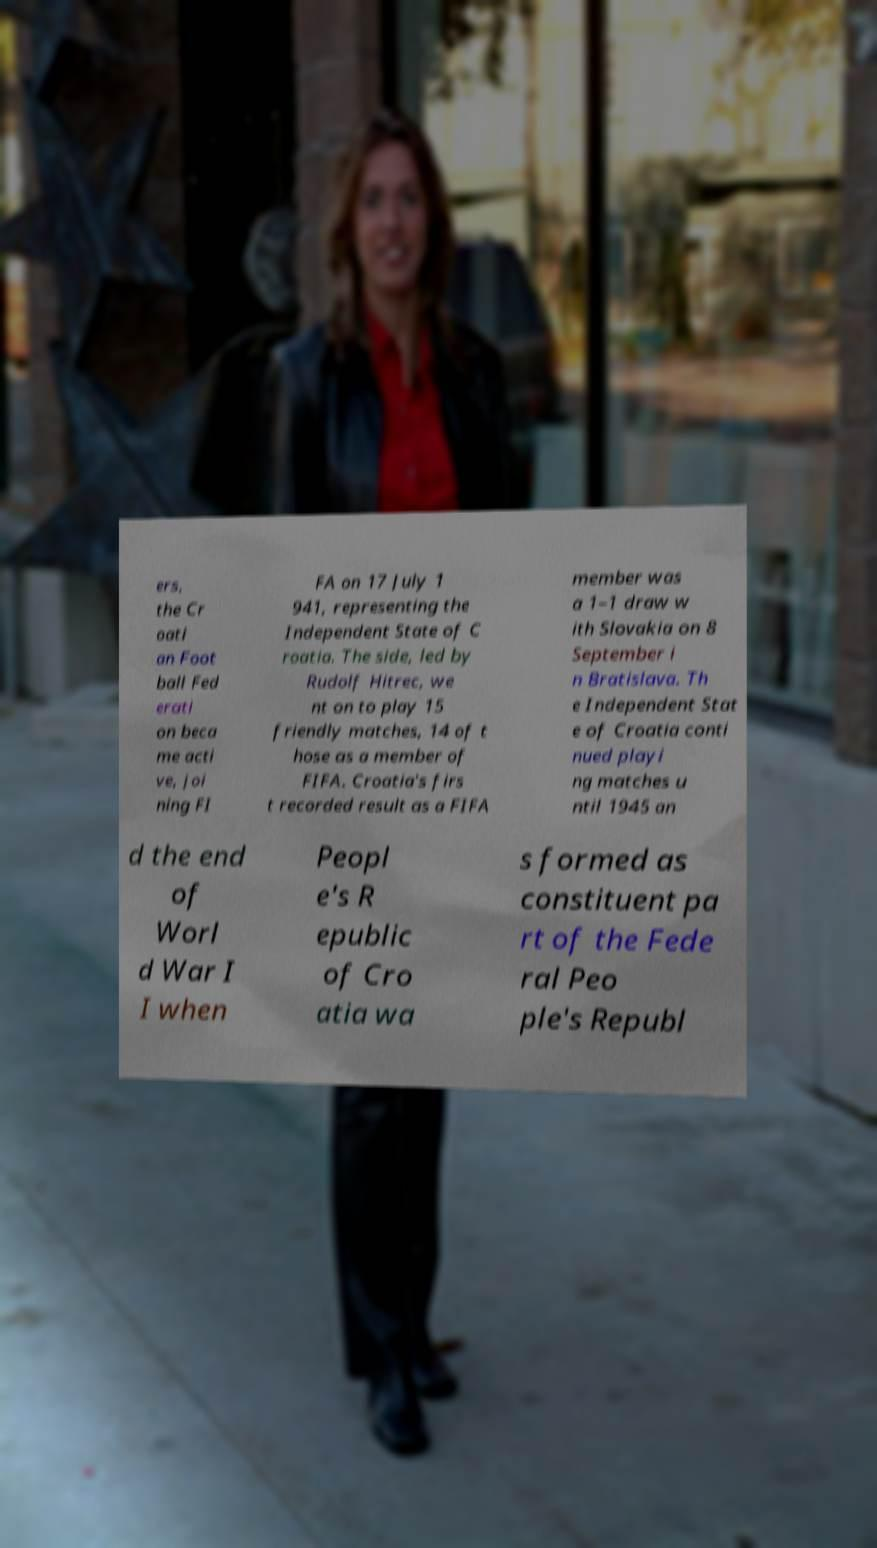For documentation purposes, I need the text within this image transcribed. Could you provide that? ers, the Cr oati an Foot ball Fed erati on beca me acti ve, joi ning FI FA on 17 July 1 941, representing the Independent State of C roatia. The side, led by Rudolf Hitrec, we nt on to play 15 friendly matches, 14 of t hose as a member of FIFA. Croatia's firs t recorded result as a FIFA member was a 1–1 draw w ith Slovakia on 8 September i n Bratislava. Th e Independent Stat e of Croatia conti nued playi ng matches u ntil 1945 an d the end of Worl d War I I when Peopl e's R epublic of Cro atia wa s formed as constituent pa rt of the Fede ral Peo ple's Republ 